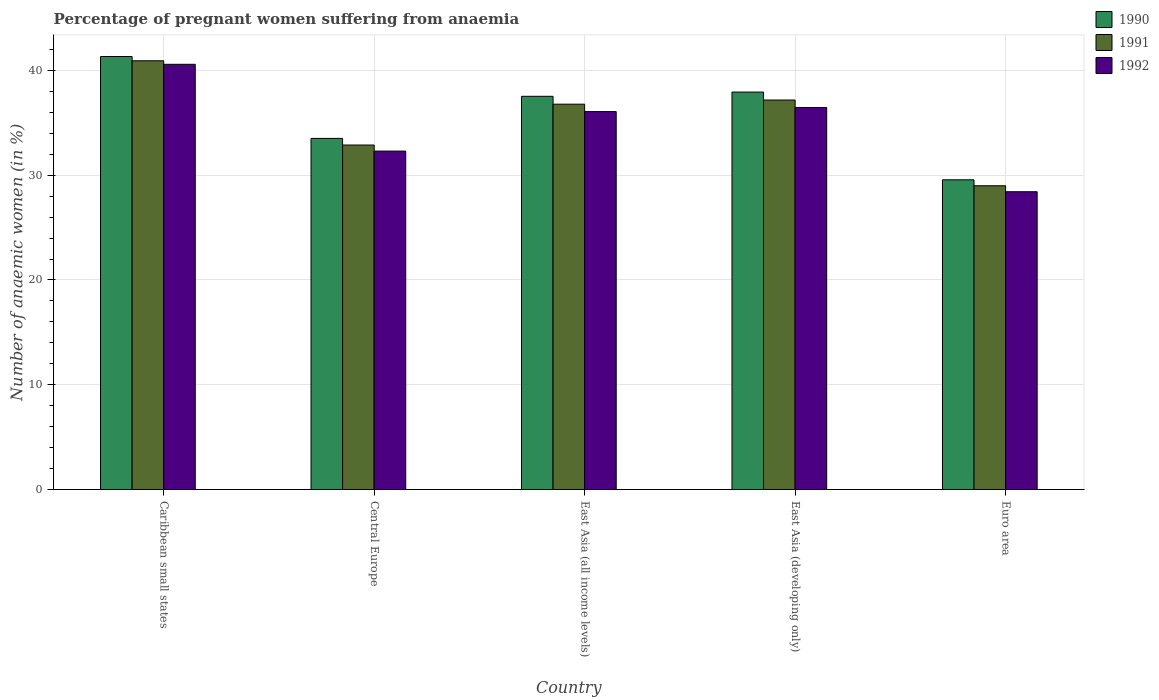How many different coloured bars are there?
Offer a very short reply. 3. How many bars are there on the 2nd tick from the left?
Ensure brevity in your answer.  3. What is the label of the 4th group of bars from the left?
Your answer should be compact. East Asia (developing only). In how many cases, is the number of bars for a given country not equal to the number of legend labels?
Offer a very short reply. 0. What is the number of anaemic women in 1990 in Caribbean small states?
Provide a succinct answer. 41.33. Across all countries, what is the maximum number of anaemic women in 1990?
Your answer should be compact. 41.33. Across all countries, what is the minimum number of anaemic women in 1992?
Your answer should be very brief. 28.43. In which country was the number of anaemic women in 1990 maximum?
Offer a terse response. Caribbean small states. What is the total number of anaemic women in 1990 in the graph?
Your answer should be very brief. 179.88. What is the difference between the number of anaemic women in 1990 in Caribbean small states and that in East Asia (developing only)?
Your response must be concise. 3.39. What is the difference between the number of anaemic women in 1991 in Euro area and the number of anaemic women in 1992 in Central Europe?
Your answer should be compact. -3.31. What is the average number of anaemic women in 1990 per country?
Your answer should be very brief. 35.98. What is the difference between the number of anaemic women of/in 1990 and number of anaemic women of/in 1992 in Euro area?
Offer a very short reply. 1.14. In how many countries, is the number of anaemic women in 1992 greater than 30 %?
Your answer should be very brief. 4. What is the ratio of the number of anaemic women in 1992 in East Asia (all income levels) to that in East Asia (developing only)?
Provide a short and direct response. 0.99. Is the number of anaemic women in 1992 in Caribbean small states less than that in Central Europe?
Provide a succinct answer. No. What is the difference between the highest and the second highest number of anaemic women in 1992?
Offer a terse response. 4.12. What is the difference between the highest and the lowest number of anaemic women in 1990?
Offer a terse response. 11.77. Is the sum of the number of anaemic women in 1991 in Caribbean small states and Central Europe greater than the maximum number of anaemic women in 1992 across all countries?
Your answer should be compact. Yes. What does the 2nd bar from the left in Euro area represents?
Make the answer very short. 1991. What does the 2nd bar from the right in Caribbean small states represents?
Your response must be concise. 1991. How many bars are there?
Provide a short and direct response. 15. Are all the bars in the graph horizontal?
Offer a very short reply. No. How many countries are there in the graph?
Give a very brief answer. 5. What is the difference between two consecutive major ticks on the Y-axis?
Keep it short and to the point. 10. Are the values on the major ticks of Y-axis written in scientific E-notation?
Offer a terse response. No. Does the graph contain grids?
Provide a short and direct response. Yes. How are the legend labels stacked?
Provide a succinct answer. Vertical. What is the title of the graph?
Your answer should be very brief. Percentage of pregnant women suffering from anaemia. What is the label or title of the Y-axis?
Your answer should be very brief. Number of anaemic women (in %). What is the Number of anaemic women (in %) of 1990 in Caribbean small states?
Your response must be concise. 41.33. What is the Number of anaemic women (in %) in 1991 in Caribbean small states?
Provide a short and direct response. 40.93. What is the Number of anaemic women (in %) of 1992 in Caribbean small states?
Your response must be concise. 40.59. What is the Number of anaemic women (in %) in 1990 in Central Europe?
Make the answer very short. 33.52. What is the Number of anaemic women (in %) of 1991 in Central Europe?
Your response must be concise. 32.88. What is the Number of anaemic women (in %) in 1992 in Central Europe?
Give a very brief answer. 32.3. What is the Number of anaemic women (in %) of 1990 in East Asia (all income levels)?
Keep it short and to the point. 37.53. What is the Number of anaemic women (in %) in 1991 in East Asia (all income levels)?
Make the answer very short. 36.78. What is the Number of anaemic women (in %) in 1992 in East Asia (all income levels)?
Ensure brevity in your answer.  36.07. What is the Number of anaemic women (in %) of 1990 in East Asia (developing only)?
Your response must be concise. 37.94. What is the Number of anaemic women (in %) of 1991 in East Asia (developing only)?
Give a very brief answer. 37.18. What is the Number of anaemic women (in %) of 1992 in East Asia (developing only)?
Give a very brief answer. 36.47. What is the Number of anaemic women (in %) of 1990 in Euro area?
Ensure brevity in your answer.  29.56. What is the Number of anaemic women (in %) in 1991 in Euro area?
Make the answer very short. 29. What is the Number of anaemic women (in %) of 1992 in Euro area?
Offer a very short reply. 28.43. Across all countries, what is the maximum Number of anaemic women (in %) in 1990?
Provide a succinct answer. 41.33. Across all countries, what is the maximum Number of anaemic women (in %) of 1991?
Your answer should be compact. 40.93. Across all countries, what is the maximum Number of anaemic women (in %) of 1992?
Provide a succinct answer. 40.59. Across all countries, what is the minimum Number of anaemic women (in %) in 1990?
Provide a succinct answer. 29.56. Across all countries, what is the minimum Number of anaemic women (in %) in 1991?
Offer a very short reply. 29. Across all countries, what is the minimum Number of anaemic women (in %) of 1992?
Ensure brevity in your answer.  28.43. What is the total Number of anaemic women (in %) in 1990 in the graph?
Make the answer very short. 179.88. What is the total Number of anaemic women (in %) of 1991 in the graph?
Ensure brevity in your answer.  176.76. What is the total Number of anaemic women (in %) of 1992 in the graph?
Give a very brief answer. 173.86. What is the difference between the Number of anaemic women (in %) of 1990 in Caribbean small states and that in Central Europe?
Offer a very short reply. 7.82. What is the difference between the Number of anaemic women (in %) of 1991 in Caribbean small states and that in Central Europe?
Your response must be concise. 8.04. What is the difference between the Number of anaemic women (in %) of 1992 in Caribbean small states and that in Central Europe?
Ensure brevity in your answer.  8.28. What is the difference between the Number of anaemic women (in %) of 1990 in Caribbean small states and that in East Asia (all income levels)?
Your response must be concise. 3.8. What is the difference between the Number of anaemic women (in %) of 1991 in Caribbean small states and that in East Asia (all income levels)?
Your answer should be very brief. 4.14. What is the difference between the Number of anaemic women (in %) in 1992 in Caribbean small states and that in East Asia (all income levels)?
Give a very brief answer. 4.51. What is the difference between the Number of anaemic women (in %) of 1990 in Caribbean small states and that in East Asia (developing only)?
Your answer should be very brief. 3.39. What is the difference between the Number of anaemic women (in %) of 1991 in Caribbean small states and that in East Asia (developing only)?
Ensure brevity in your answer.  3.75. What is the difference between the Number of anaemic women (in %) in 1992 in Caribbean small states and that in East Asia (developing only)?
Keep it short and to the point. 4.12. What is the difference between the Number of anaemic women (in %) in 1990 in Caribbean small states and that in Euro area?
Give a very brief answer. 11.77. What is the difference between the Number of anaemic women (in %) in 1991 in Caribbean small states and that in Euro area?
Your answer should be compact. 11.93. What is the difference between the Number of anaemic women (in %) of 1992 in Caribbean small states and that in Euro area?
Your answer should be compact. 12.16. What is the difference between the Number of anaemic women (in %) in 1990 in Central Europe and that in East Asia (all income levels)?
Your answer should be very brief. -4.02. What is the difference between the Number of anaemic women (in %) in 1991 in Central Europe and that in East Asia (all income levels)?
Provide a short and direct response. -3.9. What is the difference between the Number of anaemic women (in %) of 1992 in Central Europe and that in East Asia (all income levels)?
Give a very brief answer. -3.77. What is the difference between the Number of anaemic women (in %) in 1990 in Central Europe and that in East Asia (developing only)?
Your answer should be very brief. -4.42. What is the difference between the Number of anaemic women (in %) in 1991 in Central Europe and that in East Asia (developing only)?
Your answer should be very brief. -4.3. What is the difference between the Number of anaemic women (in %) of 1992 in Central Europe and that in East Asia (developing only)?
Make the answer very short. -4.16. What is the difference between the Number of anaemic women (in %) in 1990 in Central Europe and that in Euro area?
Offer a very short reply. 3.95. What is the difference between the Number of anaemic women (in %) in 1991 in Central Europe and that in Euro area?
Provide a succinct answer. 3.89. What is the difference between the Number of anaemic women (in %) in 1992 in Central Europe and that in Euro area?
Provide a succinct answer. 3.88. What is the difference between the Number of anaemic women (in %) of 1990 in East Asia (all income levels) and that in East Asia (developing only)?
Offer a very short reply. -0.41. What is the difference between the Number of anaemic women (in %) in 1991 in East Asia (all income levels) and that in East Asia (developing only)?
Your answer should be compact. -0.4. What is the difference between the Number of anaemic women (in %) in 1992 in East Asia (all income levels) and that in East Asia (developing only)?
Give a very brief answer. -0.39. What is the difference between the Number of anaemic women (in %) in 1990 in East Asia (all income levels) and that in Euro area?
Offer a terse response. 7.97. What is the difference between the Number of anaemic women (in %) in 1991 in East Asia (all income levels) and that in Euro area?
Provide a succinct answer. 7.79. What is the difference between the Number of anaemic women (in %) of 1992 in East Asia (all income levels) and that in Euro area?
Make the answer very short. 7.65. What is the difference between the Number of anaemic women (in %) in 1990 in East Asia (developing only) and that in Euro area?
Offer a terse response. 8.38. What is the difference between the Number of anaemic women (in %) of 1991 in East Asia (developing only) and that in Euro area?
Ensure brevity in your answer.  8.18. What is the difference between the Number of anaemic women (in %) in 1992 in East Asia (developing only) and that in Euro area?
Your answer should be very brief. 8.04. What is the difference between the Number of anaemic women (in %) of 1990 in Caribbean small states and the Number of anaemic women (in %) of 1991 in Central Europe?
Offer a terse response. 8.45. What is the difference between the Number of anaemic women (in %) in 1990 in Caribbean small states and the Number of anaemic women (in %) in 1992 in Central Europe?
Provide a short and direct response. 9.03. What is the difference between the Number of anaemic women (in %) in 1991 in Caribbean small states and the Number of anaemic women (in %) in 1992 in Central Europe?
Offer a terse response. 8.62. What is the difference between the Number of anaemic women (in %) in 1990 in Caribbean small states and the Number of anaemic women (in %) in 1991 in East Asia (all income levels)?
Your answer should be compact. 4.55. What is the difference between the Number of anaemic women (in %) in 1990 in Caribbean small states and the Number of anaemic women (in %) in 1992 in East Asia (all income levels)?
Ensure brevity in your answer.  5.26. What is the difference between the Number of anaemic women (in %) in 1991 in Caribbean small states and the Number of anaemic women (in %) in 1992 in East Asia (all income levels)?
Provide a succinct answer. 4.85. What is the difference between the Number of anaemic women (in %) of 1990 in Caribbean small states and the Number of anaemic women (in %) of 1991 in East Asia (developing only)?
Your answer should be very brief. 4.15. What is the difference between the Number of anaemic women (in %) of 1990 in Caribbean small states and the Number of anaemic women (in %) of 1992 in East Asia (developing only)?
Your answer should be very brief. 4.86. What is the difference between the Number of anaemic women (in %) in 1991 in Caribbean small states and the Number of anaemic women (in %) in 1992 in East Asia (developing only)?
Your response must be concise. 4.46. What is the difference between the Number of anaemic women (in %) of 1990 in Caribbean small states and the Number of anaemic women (in %) of 1991 in Euro area?
Make the answer very short. 12.34. What is the difference between the Number of anaemic women (in %) of 1990 in Caribbean small states and the Number of anaemic women (in %) of 1992 in Euro area?
Your answer should be compact. 12.9. What is the difference between the Number of anaemic women (in %) of 1991 in Caribbean small states and the Number of anaemic women (in %) of 1992 in Euro area?
Provide a succinct answer. 12.5. What is the difference between the Number of anaemic women (in %) in 1990 in Central Europe and the Number of anaemic women (in %) in 1991 in East Asia (all income levels)?
Your answer should be compact. -3.27. What is the difference between the Number of anaemic women (in %) in 1990 in Central Europe and the Number of anaemic women (in %) in 1992 in East Asia (all income levels)?
Your response must be concise. -2.56. What is the difference between the Number of anaemic women (in %) of 1991 in Central Europe and the Number of anaemic women (in %) of 1992 in East Asia (all income levels)?
Ensure brevity in your answer.  -3.19. What is the difference between the Number of anaemic women (in %) in 1990 in Central Europe and the Number of anaemic women (in %) in 1991 in East Asia (developing only)?
Make the answer very short. -3.66. What is the difference between the Number of anaemic women (in %) of 1990 in Central Europe and the Number of anaemic women (in %) of 1992 in East Asia (developing only)?
Give a very brief answer. -2.95. What is the difference between the Number of anaemic women (in %) in 1991 in Central Europe and the Number of anaemic women (in %) in 1992 in East Asia (developing only)?
Provide a short and direct response. -3.58. What is the difference between the Number of anaemic women (in %) in 1990 in Central Europe and the Number of anaemic women (in %) in 1991 in Euro area?
Your answer should be very brief. 4.52. What is the difference between the Number of anaemic women (in %) in 1990 in Central Europe and the Number of anaemic women (in %) in 1992 in Euro area?
Your response must be concise. 5.09. What is the difference between the Number of anaemic women (in %) of 1991 in Central Europe and the Number of anaemic women (in %) of 1992 in Euro area?
Ensure brevity in your answer.  4.46. What is the difference between the Number of anaemic women (in %) in 1990 in East Asia (all income levels) and the Number of anaemic women (in %) in 1991 in East Asia (developing only)?
Provide a short and direct response. 0.35. What is the difference between the Number of anaemic women (in %) in 1990 in East Asia (all income levels) and the Number of anaemic women (in %) in 1992 in East Asia (developing only)?
Offer a very short reply. 1.07. What is the difference between the Number of anaemic women (in %) in 1991 in East Asia (all income levels) and the Number of anaemic women (in %) in 1992 in East Asia (developing only)?
Your response must be concise. 0.32. What is the difference between the Number of anaemic women (in %) in 1990 in East Asia (all income levels) and the Number of anaemic women (in %) in 1991 in Euro area?
Give a very brief answer. 8.54. What is the difference between the Number of anaemic women (in %) in 1990 in East Asia (all income levels) and the Number of anaemic women (in %) in 1992 in Euro area?
Make the answer very short. 9.11. What is the difference between the Number of anaemic women (in %) in 1991 in East Asia (all income levels) and the Number of anaemic women (in %) in 1992 in Euro area?
Offer a very short reply. 8.36. What is the difference between the Number of anaemic women (in %) in 1990 in East Asia (developing only) and the Number of anaemic women (in %) in 1991 in Euro area?
Give a very brief answer. 8.94. What is the difference between the Number of anaemic women (in %) in 1990 in East Asia (developing only) and the Number of anaemic women (in %) in 1992 in Euro area?
Your response must be concise. 9.51. What is the difference between the Number of anaemic women (in %) in 1991 in East Asia (developing only) and the Number of anaemic women (in %) in 1992 in Euro area?
Offer a terse response. 8.75. What is the average Number of anaemic women (in %) of 1990 per country?
Make the answer very short. 35.98. What is the average Number of anaemic women (in %) in 1991 per country?
Provide a short and direct response. 35.35. What is the average Number of anaemic women (in %) of 1992 per country?
Offer a very short reply. 34.77. What is the difference between the Number of anaemic women (in %) of 1990 and Number of anaemic women (in %) of 1991 in Caribbean small states?
Your response must be concise. 0.41. What is the difference between the Number of anaemic women (in %) in 1990 and Number of anaemic women (in %) in 1992 in Caribbean small states?
Offer a very short reply. 0.74. What is the difference between the Number of anaemic women (in %) of 1991 and Number of anaemic women (in %) of 1992 in Caribbean small states?
Make the answer very short. 0.34. What is the difference between the Number of anaemic women (in %) of 1990 and Number of anaemic women (in %) of 1991 in Central Europe?
Offer a very short reply. 0.63. What is the difference between the Number of anaemic women (in %) of 1990 and Number of anaemic women (in %) of 1992 in Central Europe?
Ensure brevity in your answer.  1.21. What is the difference between the Number of anaemic women (in %) in 1991 and Number of anaemic women (in %) in 1992 in Central Europe?
Make the answer very short. 0.58. What is the difference between the Number of anaemic women (in %) in 1990 and Number of anaemic women (in %) in 1991 in East Asia (all income levels)?
Offer a terse response. 0.75. What is the difference between the Number of anaemic women (in %) in 1990 and Number of anaemic women (in %) in 1992 in East Asia (all income levels)?
Provide a short and direct response. 1.46. What is the difference between the Number of anaemic women (in %) in 1991 and Number of anaemic women (in %) in 1992 in East Asia (all income levels)?
Ensure brevity in your answer.  0.71. What is the difference between the Number of anaemic women (in %) in 1990 and Number of anaemic women (in %) in 1991 in East Asia (developing only)?
Give a very brief answer. 0.76. What is the difference between the Number of anaemic women (in %) in 1990 and Number of anaemic women (in %) in 1992 in East Asia (developing only)?
Offer a very short reply. 1.47. What is the difference between the Number of anaemic women (in %) of 1991 and Number of anaemic women (in %) of 1992 in East Asia (developing only)?
Your answer should be very brief. 0.71. What is the difference between the Number of anaemic women (in %) in 1990 and Number of anaemic women (in %) in 1991 in Euro area?
Keep it short and to the point. 0.57. What is the difference between the Number of anaemic women (in %) of 1990 and Number of anaemic women (in %) of 1992 in Euro area?
Make the answer very short. 1.14. What is the difference between the Number of anaemic women (in %) in 1991 and Number of anaemic women (in %) in 1992 in Euro area?
Offer a very short reply. 0.57. What is the ratio of the Number of anaemic women (in %) in 1990 in Caribbean small states to that in Central Europe?
Provide a succinct answer. 1.23. What is the ratio of the Number of anaemic women (in %) in 1991 in Caribbean small states to that in Central Europe?
Keep it short and to the point. 1.24. What is the ratio of the Number of anaemic women (in %) in 1992 in Caribbean small states to that in Central Europe?
Provide a succinct answer. 1.26. What is the ratio of the Number of anaemic women (in %) in 1990 in Caribbean small states to that in East Asia (all income levels)?
Offer a very short reply. 1.1. What is the ratio of the Number of anaemic women (in %) of 1991 in Caribbean small states to that in East Asia (all income levels)?
Give a very brief answer. 1.11. What is the ratio of the Number of anaemic women (in %) in 1992 in Caribbean small states to that in East Asia (all income levels)?
Give a very brief answer. 1.13. What is the ratio of the Number of anaemic women (in %) of 1990 in Caribbean small states to that in East Asia (developing only)?
Make the answer very short. 1.09. What is the ratio of the Number of anaemic women (in %) of 1991 in Caribbean small states to that in East Asia (developing only)?
Give a very brief answer. 1.1. What is the ratio of the Number of anaemic women (in %) in 1992 in Caribbean small states to that in East Asia (developing only)?
Your answer should be very brief. 1.11. What is the ratio of the Number of anaemic women (in %) of 1990 in Caribbean small states to that in Euro area?
Your answer should be very brief. 1.4. What is the ratio of the Number of anaemic women (in %) in 1991 in Caribbean small states to that in Euro area?
Offer a very short reply. 1.41. What is the ratio of the Number of anaemic women (in %) of 1992 in Caribbean small states to that in Euro area?
Offer a very short reply. 1.43. What is the ratio of the Number of anaemic women (in %) of 1990 in Central Europe to that in East Asia (all income levels)?
Give a very brief answer. 0.89. What is the ratio of the Number of anaemic women (in %) in 1991 in Central Europe to that in East Asia (all income levels)?
Make the answer very short. 0.89. What is the ratio of the Number of anaemic women (in %) of 1992 in Central Europe to that in East Asia (all income levels)?
Your answer should be compact. 0.9. What is the ratio of the Number of anaemic women (in %) in 1990 in Central Europe to that in East Asia (developing only)?
Make the answer very short. 0.88. What is the ratio of the Number of anaemic women (in %) in 1991 in Central Europe to that in East Asia (developing only)?
Your answer should be compact. 0.88. What is the ratio of the Number of anaemic women (in %) in 1992 in Central Europe to that in East Asia (developing only)?
Your answer should be compact. 0.89. What is the ratio of the Number of anaemic women (in %) of 1990 in Central Europe to that in Euro area?
Your answer should be compact. 1.13. What is the ratio of the Number of anaemic women (in %) in 1991 in Central Europe to that in Euro area?
Your response must be concise. 1.13. What is the ratio of the Number of anaemic women (in %) of 1992 in Central Europe to that in Euro area?
Offer a terse response. 1.14. What is the ratio of the Number of anaemic women (in %) of 1990 in East Asia (all income levels) to that in East Asia (developing only)?
Ensure brevity in your answer.  0.99. What is the ratio of the Number of anaemic women (in %) of 1991 in East Asia (all income levels) to that in East Asia (developing only)?
Give a very brief answer. 0.99. What is the ratio of the Number of anaemic women (in %) of 1992 in East Asia (all income levels) to that in East Asia (developing only)?
Make the answer very short. 0.99. What is the ratio of the Number of anaemic women (in %) of 1990 in East Asia (all income levels) to that in Euro area?
Provide a succinct answer. 1.27. What is the ratio of the Number of anaemic women (in %) in 1991 in East Asia (all income levels) to that in Euro area?
Give a very brief answer. 1.27. What is the ratio of the Number of anaemic women (in %) of 1992 in East Asia (all income levels) to that in Euro area?
Your answer should be very brief. 1.27. What is the ratio of the Number of anaemic women (in %) in 1990 in East Asia (developing only) to that in Euro area?
Offer a very short reply. 1.28. What is the ratio of the Number of anaemic women (in %) of 1991 in East Asia (developing only) to that in Euro area?
Make the answer very short. 1.28. What is the ratio of the Number of anaemic women (in %) of 1992 in East Asia (developing only) to that in Euro area?
Provide a short and direct response. 1.28. What is the difference between the highest and the second highest Number of anaemic women (in %) in 1990?
Make the answer very short. 3.39. What is the difference between the highest and the second highest Number of anaemic women (in %) in 1991?
Provide a short and direct response. 3.75. What is the difference between the highest and the second highest Number of anaemic women (in %) in 1992?
Keep it short and to the point. 4.12. What is the difference between the highest and the lowest Number of anaemic women (in %) of 1990?
Offer a very short reply. 11.77. What is the difference between the highest and the lowest Number of anaemic women (in %) in 1991?
Keep it short and to the point. 11.93. What is the difference between the highest and the lowest Number of anaemic women (in %) of 1992?
Provide a succinct answer. 12.16. 